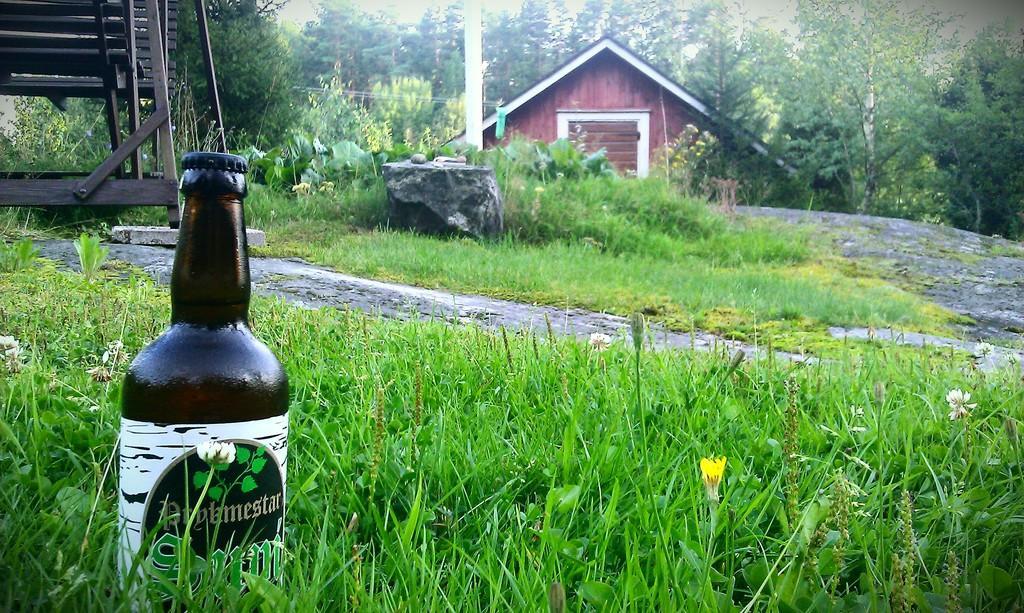Can you describe this image briefly? In the image we can see there is a wine bottle which is kept on the grass. On the back there is a house and behind the house there are lot of trees. 